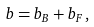Convert formula to latex. <formula><loc_0><loc_0><loc_500><loc_500>b = b _ { B } + b _ { F } \, ,</formula> 